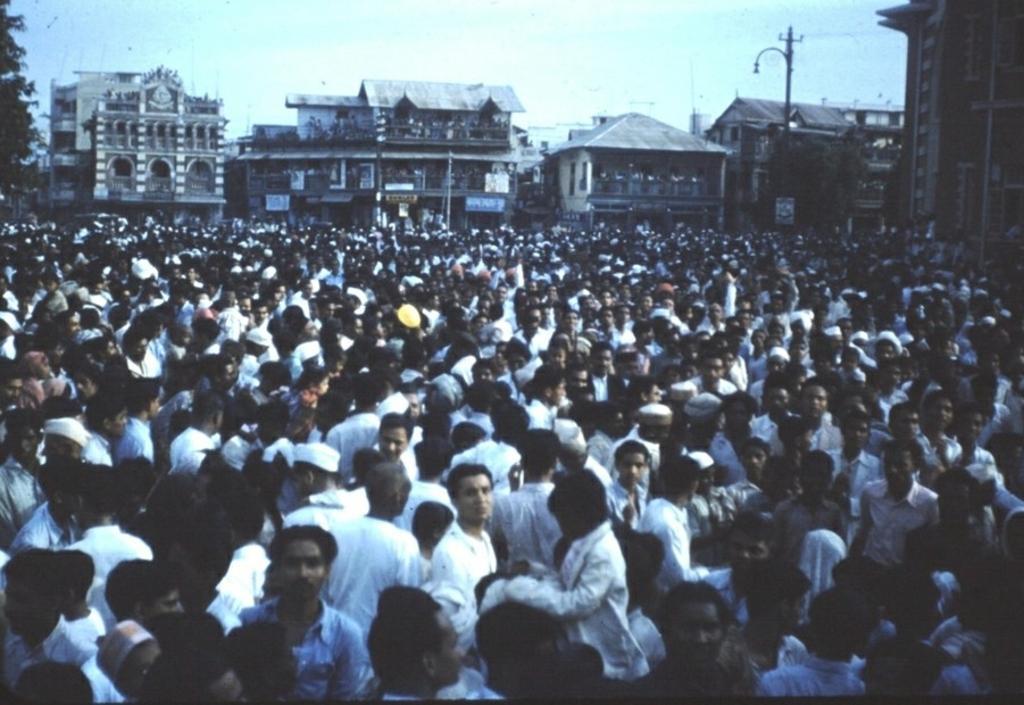Please provide a concise description of this image. In this image, we can see a crowd in front of buildings. There is pole in the top right of the image. At the top of the image, we can see the sky. 